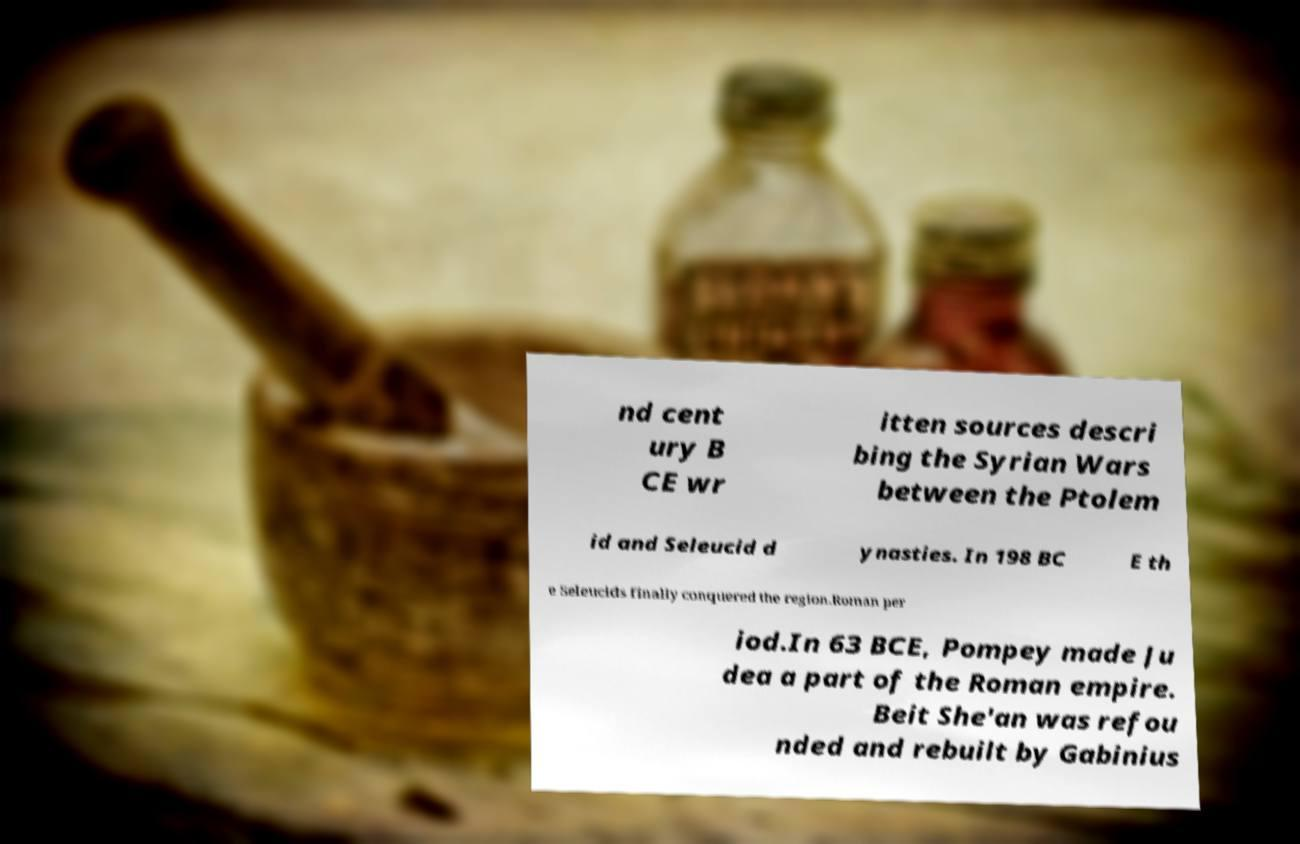Could you extract and type out the text from this image? nd cent ury B CE wr itten sources descri bing the Syrian Wars between the Ptolem id and Seleucid d ynasties. In 198 BC E th e Seleucids finally conquered the region.Roman per iod.In 63 BCE, Pompey made Ju dea a part of the Roman empire. Beit She'an was refou nded and rebuilt by Gabinius 